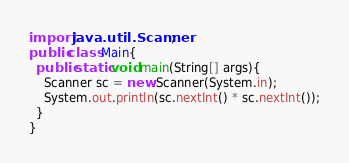<code> <loc_0><loc_0><loc_500><loc_500><_Java_>import java.util.Scanner;
public class Main{
  public static void main(String[] args){
    Scanner sc = new Scanner(System.in);
    System.out.println(sc.nextInt() * sc.nextInt());
  }
}</code> 